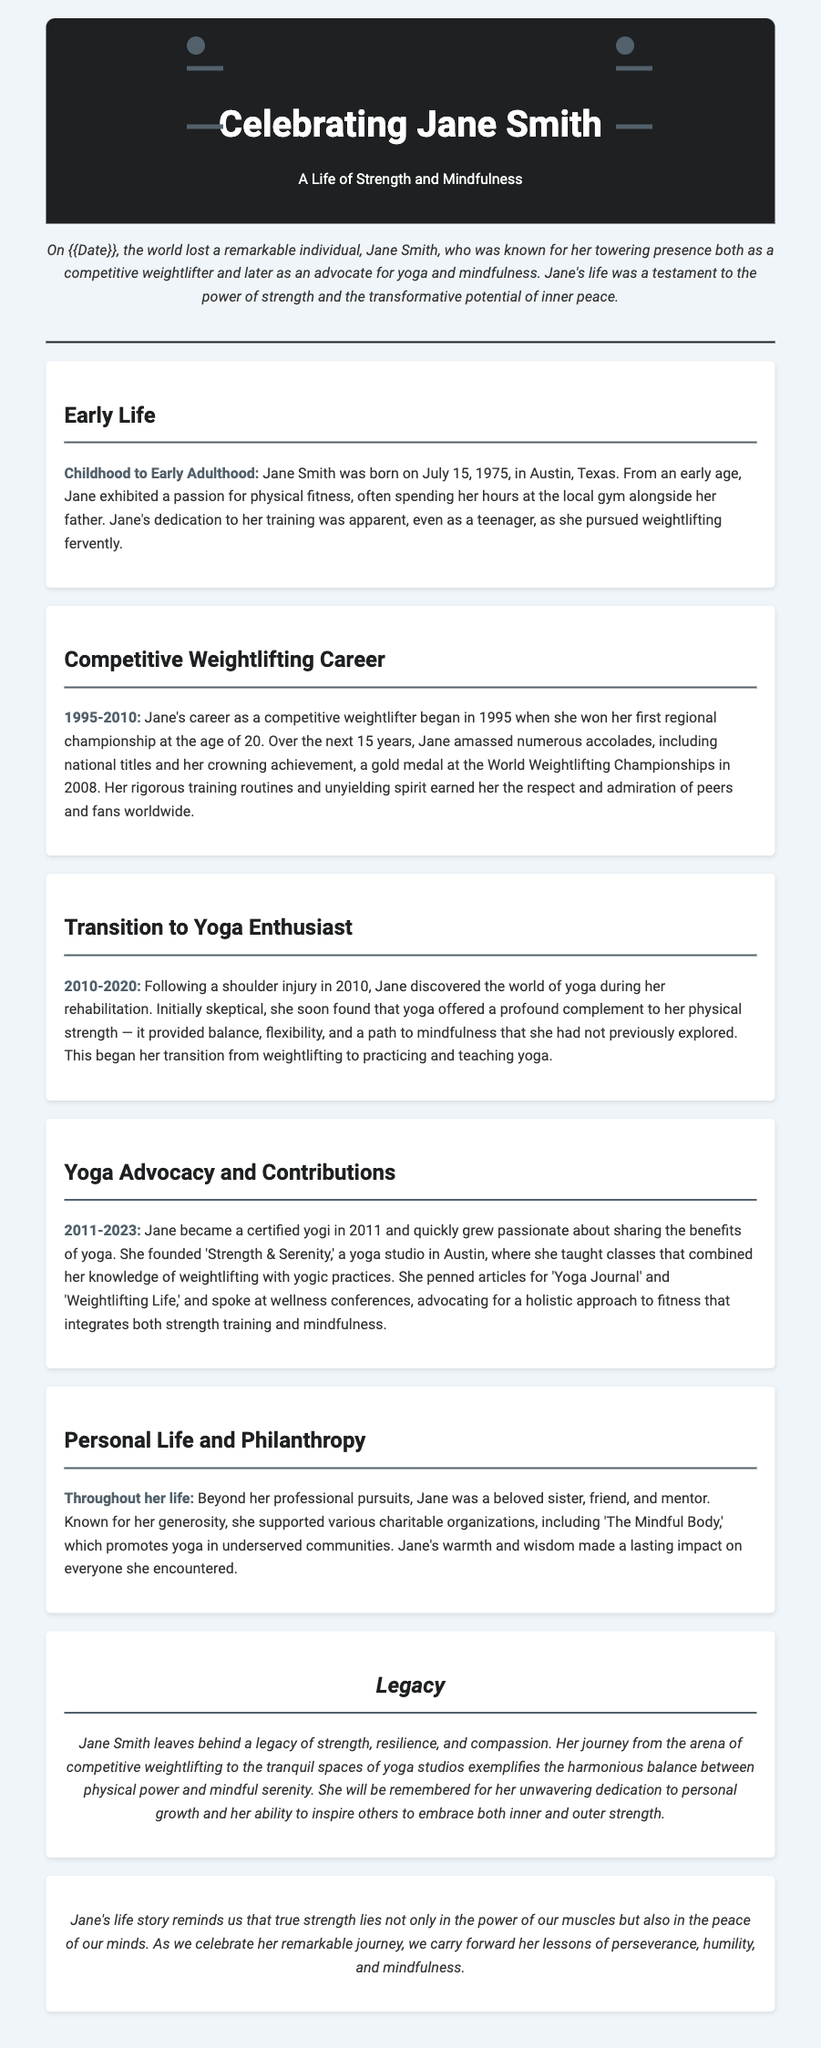what was Jane Smith's birth date? The birth date of Jane Smith is provided in the Early Life section.
Answer: July 15, 1975 what did Jane achieve in 2008? The document states that Jane's crowning achievement was winning a gold medal at the World Weightlifting Championships in 2008.
Answer: Gold medal at the World Weightlifting Championships what injury led Jane to discover yoga? The transition to yoga was triggered by an injury Jane sustained during her career.
Answer: Shoulder injury what did Jane found in Austin? The document mentions that Jane founded a yoga studio in Austin.
Answer: Strength & Serenity how many years did Jane compete in weightlifting? The timeline in the Competitive Weightlifting Career section indicates the years of her competitive career.
Answer: 15 years what was Jane’s main focus in her later years? The latter part of Jane's life focused on sharing yoga and mindfulness through her studio and writings.
Answer: Yoga and mindfulness which philanthropic organization did Jane support? Throughout her life, Jane supported various charitable organizations, one of which is mentioned in the Personal Life and Philanthropy section.
Answer: The Mindful Body what is a significant theme in Jane's legacy? The legacy section highlights a major theme in Jane's life that exemplifies her journey.
Answer: Strength and mindfulness 